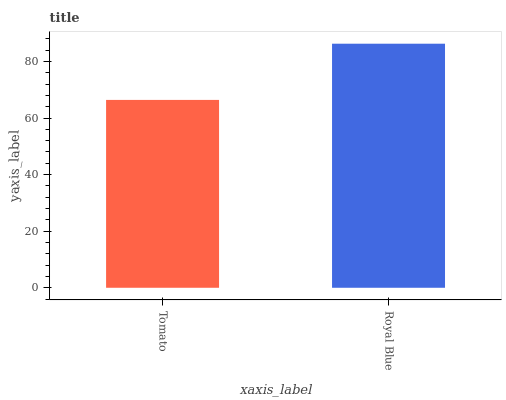Is Tomato the minimum?
Answer yes or no. Yes. Is Royal Blue the maximum?
Answer yes or no. Yes. Is Royal Blue the minimum?
Answer yes or no. No. Is Royal Blue greater than Tomato?
Answer yes or no. Yes. Is Tomato less than Royal Blue?
Answer yes or no. Yes. Is Tomato greater than Royal Blue?
Answer yes or no. No. Is Royal Blue less than Tomato?
Answer yes or no. No. Is Royal Blue the high median?
Answer yes or no. Yes. Is Tomato the low median?
Answer yes or no. Yes. Is Tomato the high median?
Answer yes or no. No. Is Royal Blue the low median?
Answer yes or no. No. 